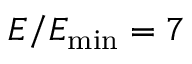Convert formula to latex. <formula><loc_0><loc_0><loc_500><loc_500>E / E _ { \min } = 7</formula> 